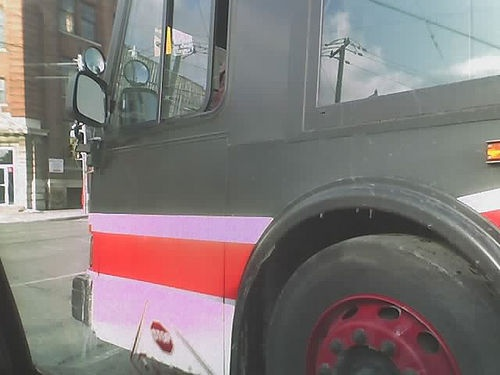Describe the objects in this image and their specific colors. I can see bus in gray, beige, darkgray, black, and pink tones in this image. 